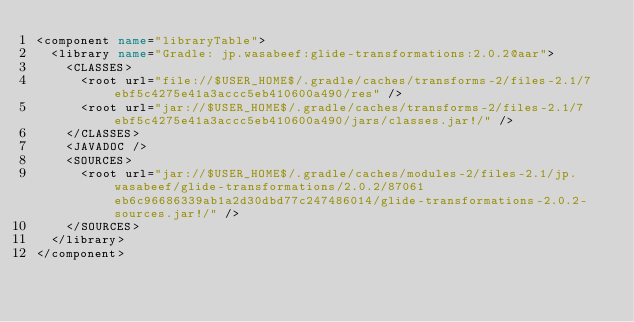<code> <loc_0><loc_0><loc_500><loc_500><_XML_><component name="libraryTable">
  <library name="Gradle: jp.wasabeef:glide-transformations:2.0.2@aar">
    <CLASSES>
      <root url="file://$USER_HOME$/.gradle/caches/transforms-2/files-2.1/7ebf5c4275e41a3accc5eb410600a490/res" />
      <root url="jar://$USER_HOME$/.gradle/caches/transforms-2/files-2.1/7ebf5c4275e41a3accc5eb410600a490/jars/classes.jar!/" />
    </CLASSES>
    <JAVADOC />
    <SOURCES>
      <root url="jar://$USER_HOME$/.gradle/caches/modules-2/files-2.1/jp.wasabeef/glide-transformations/2.0.2/87061eb6c96686339ab1a2d30dbd77c247486014/glide-transformations-2.0.2-sources.jar!/" />
    </SOURCES>
  </library>
</component></code> 